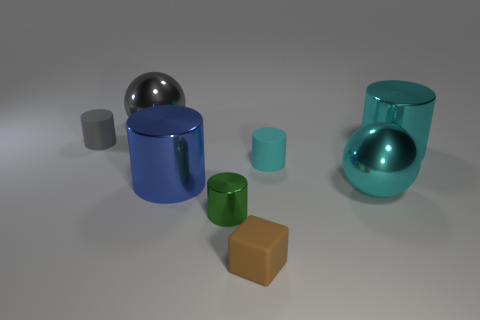What number of rubber cylinders are there?
Make the answer very short. 2. There is a cyan metallic thing behind the ball that is on the right side of the small brown block; what is its shape?
Give a very brief answer. Cylinder. What number of green things are behind the gray metal sphere?
Your answer should be very brief. 0. Is the material of the tiny cyan cylinder the same as the big blue cylinder that is left of the brown rubber block?
Make the answer very short. No. Is there a green metallic cylinder of the same size as the cyan sphere?
Your answer should be compact. No. Are there the same number of big gray spheres right of the rubber block and purple metallic spheres?
Offer a very short reply. Yes. What size is the green object?
Your answer should be compact. Small. There is a green shiny cylinder that is in front of the large blue thing; how many big cylinders are on the right side of it?
Your answer should be compact. 1. There is a big thing that is behind the blue metal cylinder and on the right side of the big blue thing; what is its shape?
Ensure brevity in your answer.  Cylinder. What number of metal cylinders have the same color as the tiny shiny object?
Keep it short and to the point. 0. 